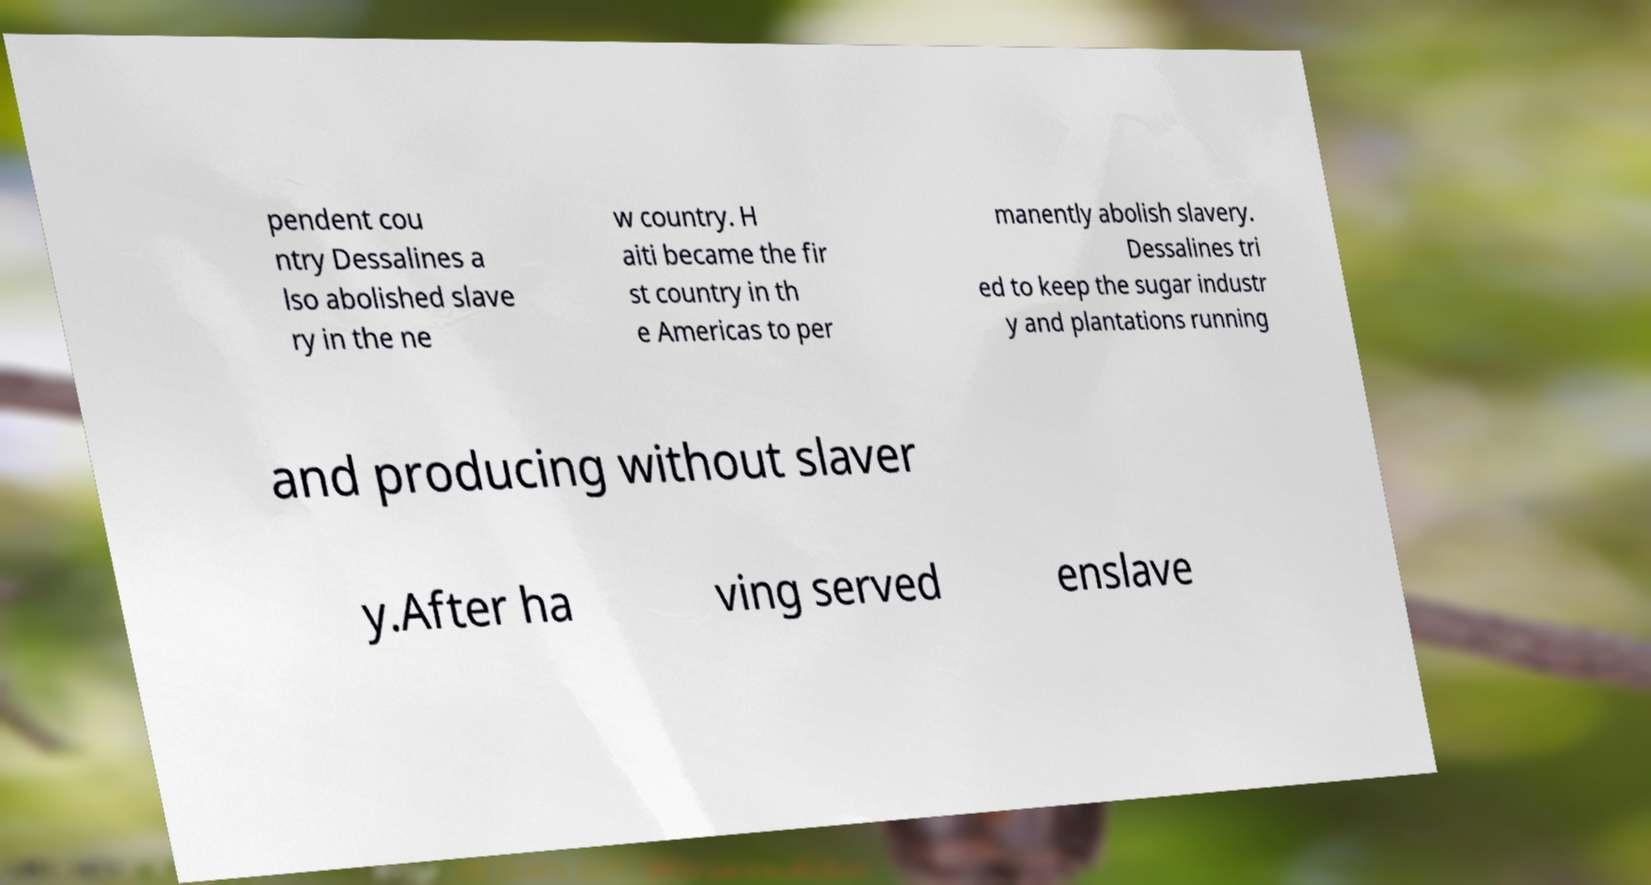For documentation purposes, I need the text within this image transcribed. Could you provide that? pendent cou ntry Dessalines a lso abolished slave ry in the ne w country. H aiti became the fir st country in th e Americas to per manently abolish slavery. Dessalines tri ed to keep the sugar industr y and plantations running and producing without slaver y.After ha ving served enslave 